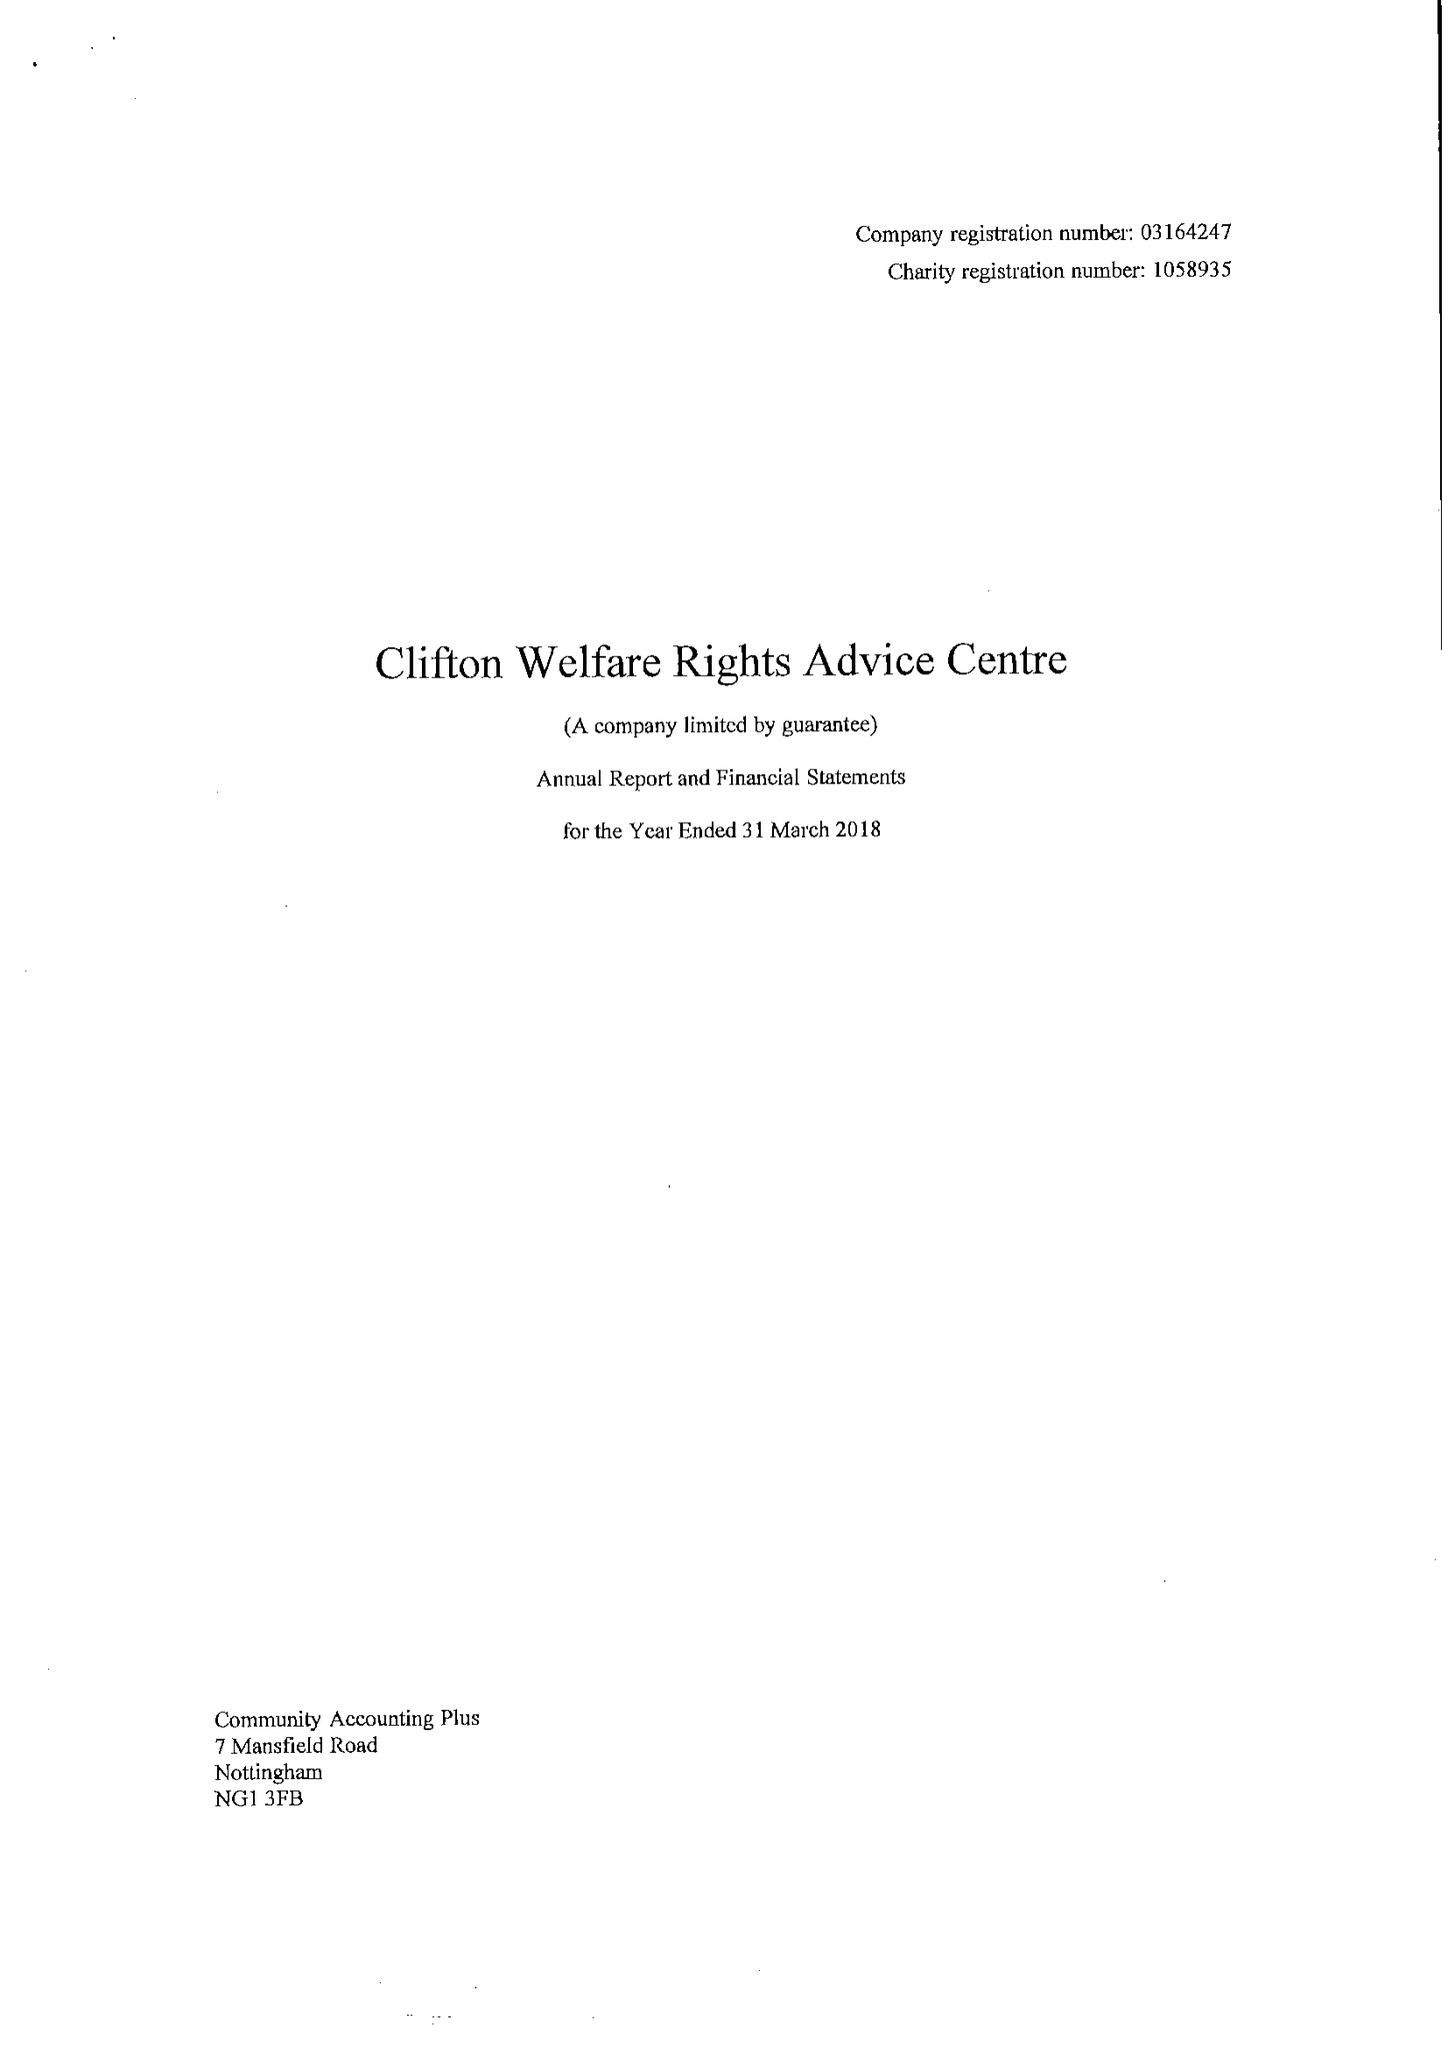What is the value for the income_annually_in_british_pounds?
Answer the question using a single word or phrase. 77856.00 